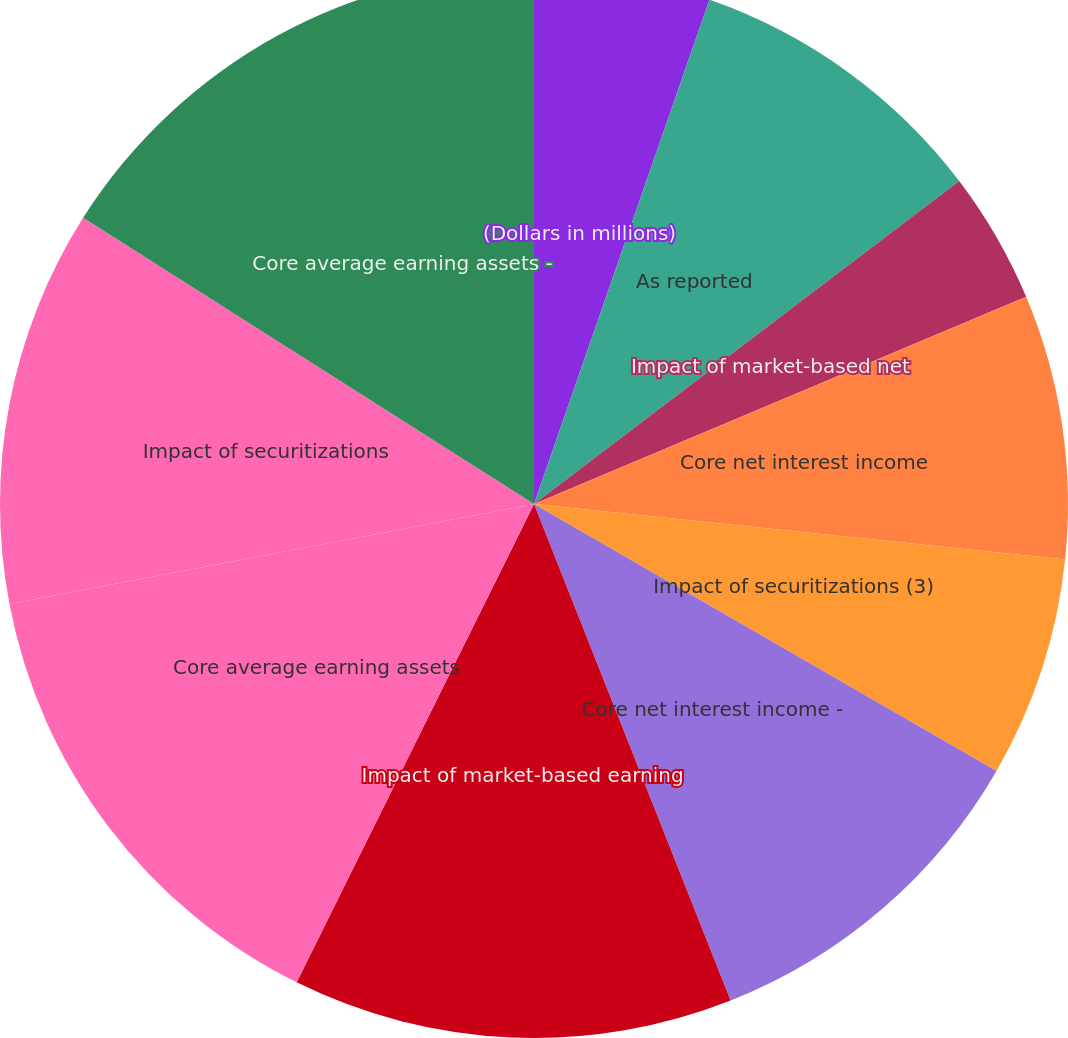Convert chart. <chart><loc_0><loc_0><loc_500><loc_500><pie_chart><fcel>(Dollars in millions)<fcel>As reported<fcel>Impact of market-based net<fcel>Core net interest income<fcel>Impact of securitizations (3)<fcel>Core net interest income -<fcel>Impact of market-based earning<fcel>Core average earning assets<fcel>Impact of securitizations<fcel>Core average earning assets -<nl><fcel>5.33%<fcel>9.33%<fcel>4.0%<fcel>8.0%<fcel>6.67%<fcel>10.67%<fcel>13.33%<fcel>14.67%<fcel>12.0%<fcel>16.0%<nl></chart> 